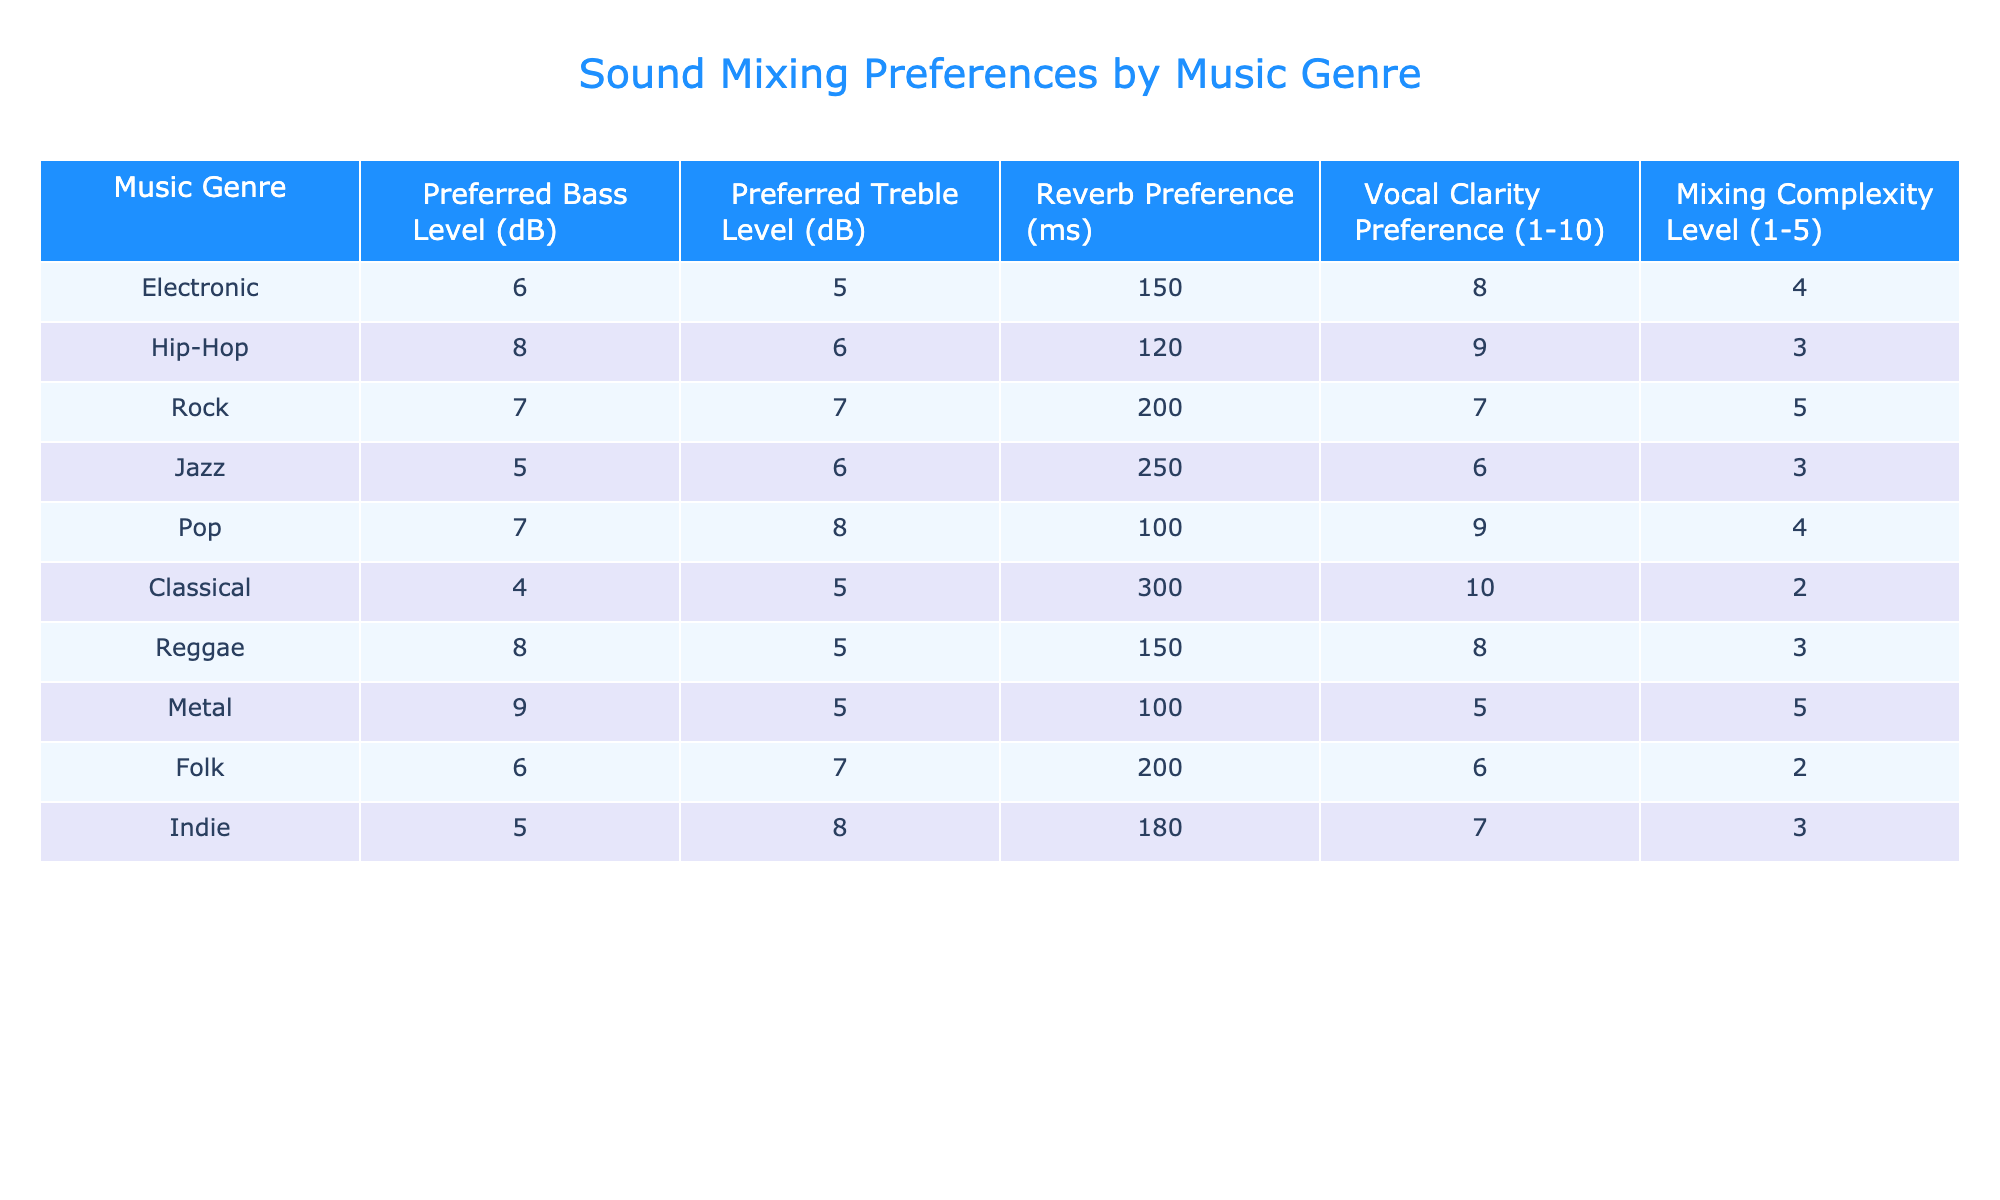What is the preferred bass level for Hip-Hop? The table indicates the preferred bass level for Hip-Hop, which is listed as 8 dB.
Answer: 8 dB Which genre has the highest vocal clarity preference? Looking at the vocal clarity preference column, Classical has a preference of 10, which is the highest among all genres.
Answer: Classical What is the average preferred treble level for Rock and Metal? The preferred treble levels for Rock and Metal are 7 dB and 5 dB respectively. To find the average, add them (7 + 5 = 12) and divide by 2, resulting in 12/2 = 6 dB.
Answer: 6 dB Does Jazz have a higher preferred reverb time than Electronic? The preferred reverb time for Jazz is 250 ms and for Electronic is 150 ms, so Jazz does have a higher value.
Answer: Yes Which music genre prefers the lowest bass level and what is that level? The genres listed show Classical with a preferred bass level of 4 dB, which is the lowest when compared to others.
Answer: 4 dB What is the difference in preferred reverb time between Pop and Folk? Pop has a preferred reverb time of 100 ms, while Folk has 200 ms. The difference is calculated by subtracting the two values (200 - 100 = 100 ms).
Answer: 100 ms Are there more genres that prefer a bass level of 8 dB or 6 dB? Upon checking the table, Hip-Hop and Reggae both prefer 8 dB, while Electronic and Folk prefer 6 dB, making it a tie with two genres for each value.
Answer: Tie, 2 for each What is the sum of the mixing complexity levels for Jazz and Classical? The mixing complexity level for Jazz is 3 and for Classical is 2. Adding these together (3 + 2) gives a total of 5.
Answer: 5 Which genre has the lowest mixing complexity level, and what is the value? The table shows that Classical has a mixing complexity level of 2, which is the lowest among the genres listed.
Answer: Classical, 2 